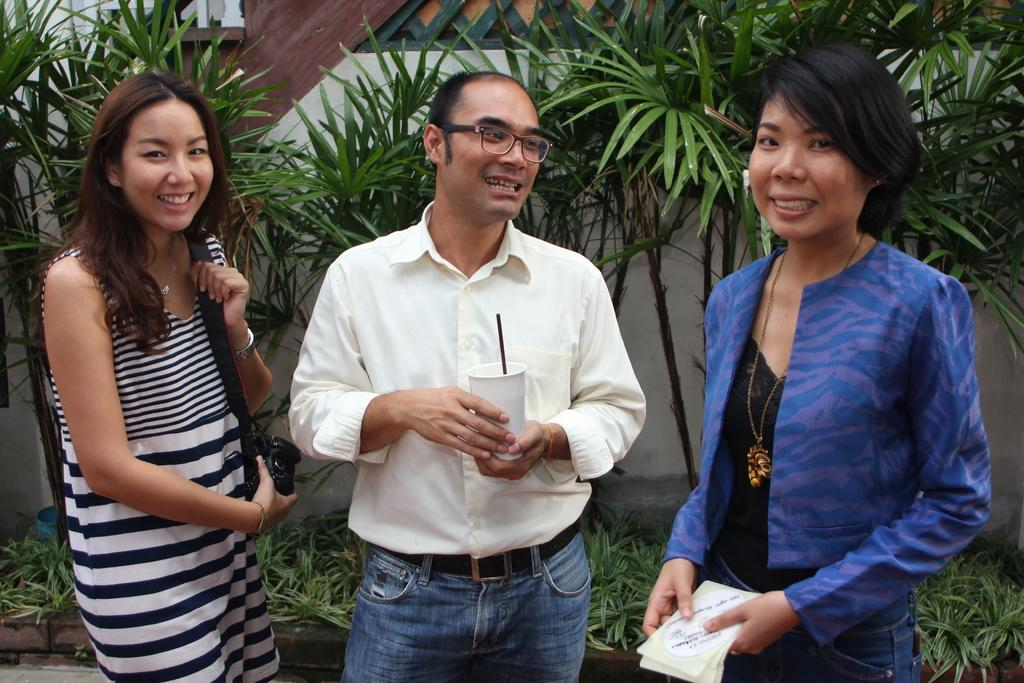What are the people in the image doing? The people in the image are standing and holding a camera, a cup, and papers. What can be seen in the background of the image? There are plants and trees visible in the background, as well as a wall. What type of wool is being pulled by the people in the image? There is no wool present in the image, and the people are not pulling anything. 